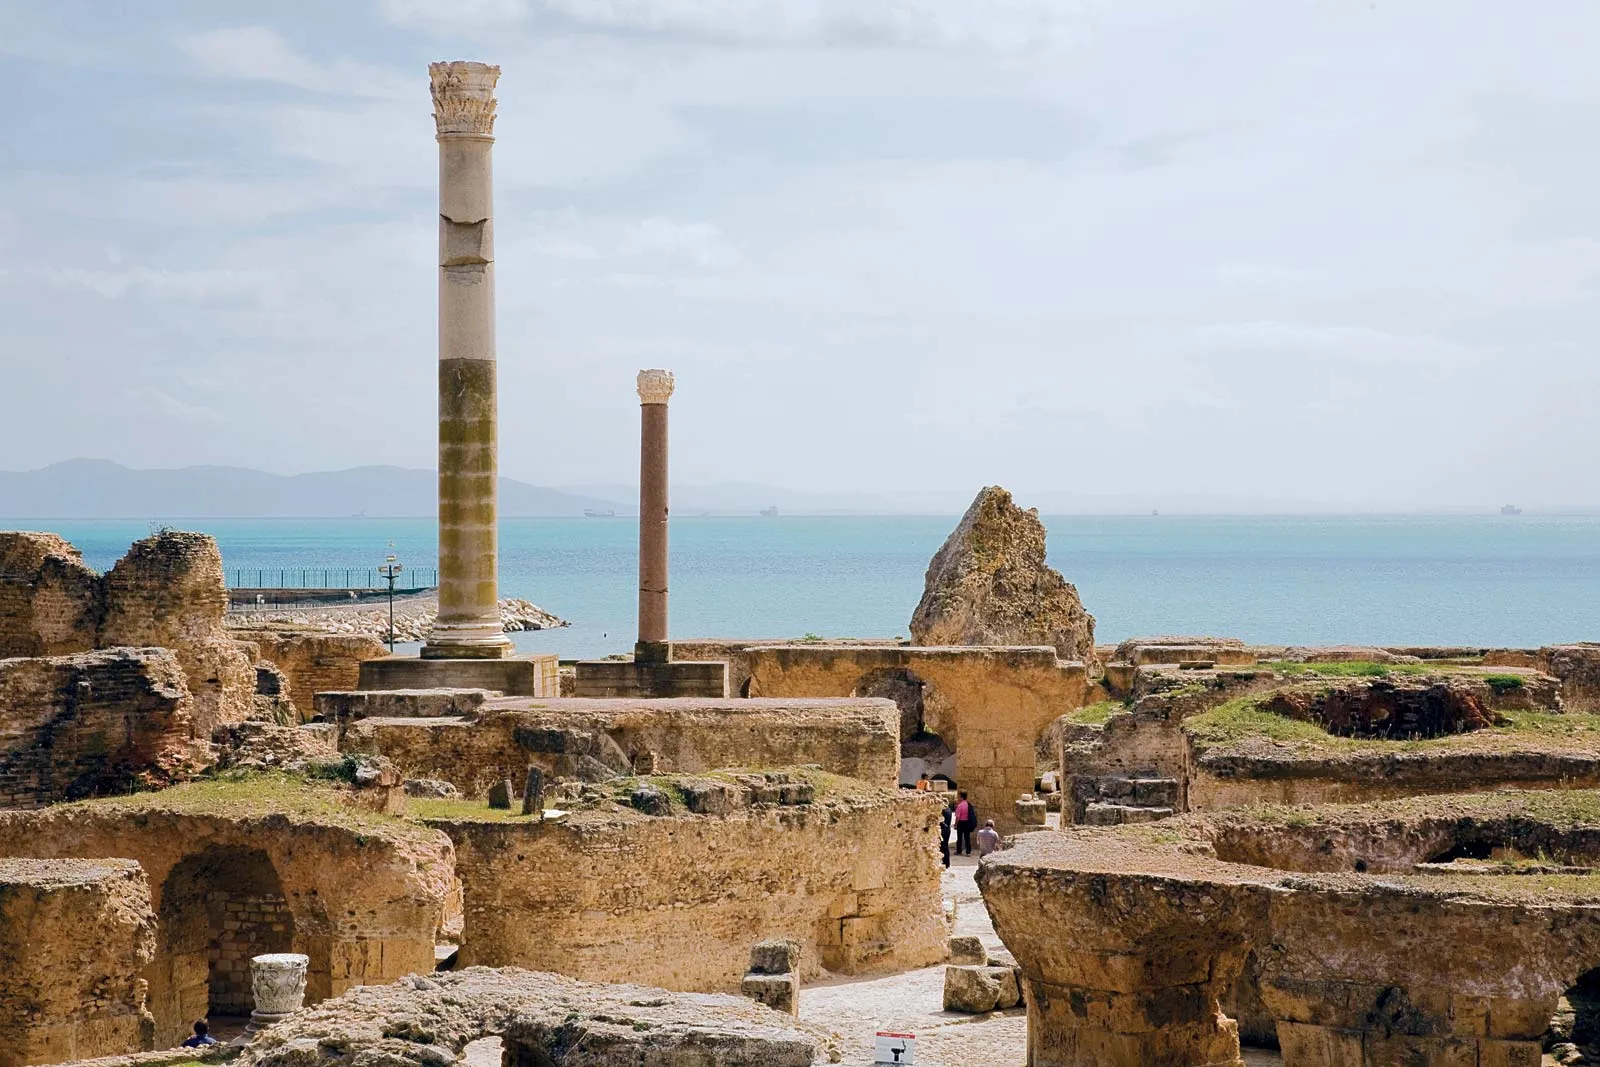What are the specific architectural features visible in this image? The image prominently displays ancient Roman architecture, characteristic of the reconstructed city of Carthage during the Roman era. Visible are the tall, cylindrical stone columns, some of which are still intact while others have toppled over or broken into pieces. The structured layout of the stones and the methodic placement of the columns suggest a forum or public gathering area, typical of Roman cities for communal activities and social gatherings. 